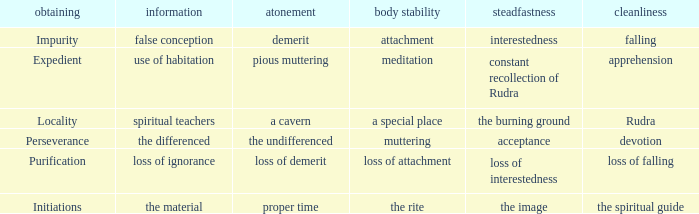 what's the permanence of the body where constancy is interestedness Attachment. 